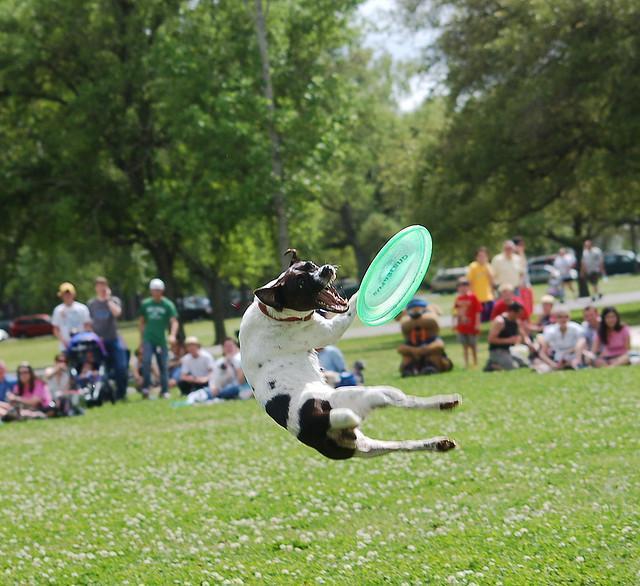How many people can be seen?
Give a very brief answer. 5. 